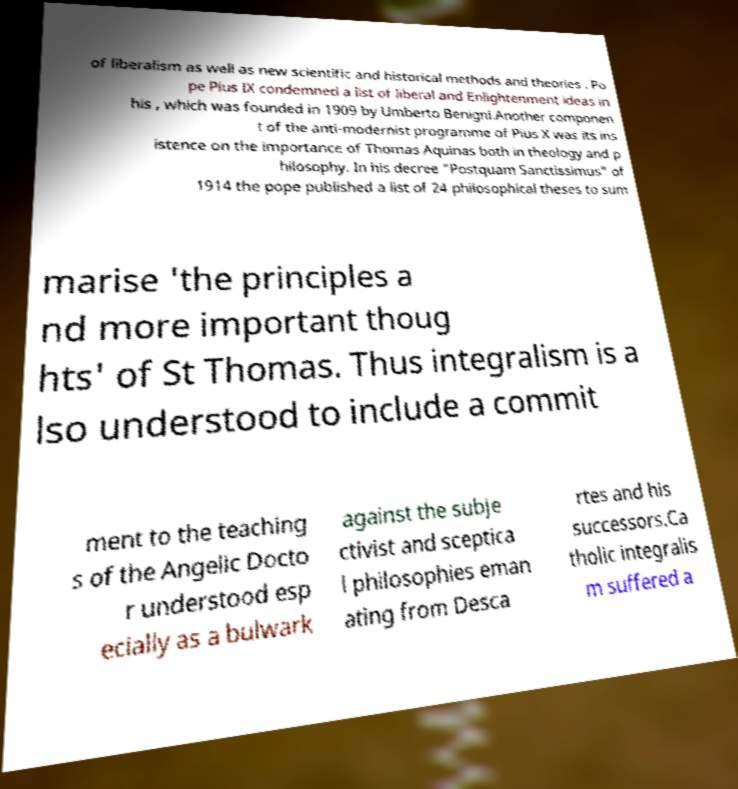For documentation purposes, I need the text within this image transcribed. Could you provide that? of liberalism as well as new scientific and historical methods and theories . Po pe Pius IX condemned a list of liberal and Enlightenment ideas in his , which was founded in 1909 by Umberto Benigni.Another componen t of the anti-modernist programme of Pius X was its ins istence on the importance of Thomas Aquinas both in theology and p hilosophy. In his decree "Postquam Sanctissimus" of 1914 the pope published a list of 24 philosophical theses to sum marise 'the principles a nd more important thoug hts' of St Thomas. Thus integralism is a lso understood to include a commit ment to the teaching s of the Angelic Docto r understood esp ecially as a bulwark against the subje ctivist and sceptica l philosophies eman ating from Desca rtes and his successors.Ca tholic integralis m suffered a 